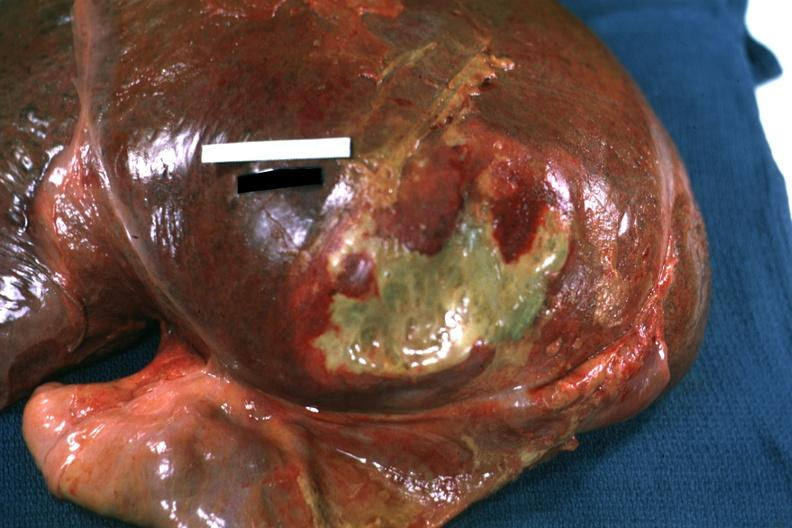how is right leaf of diaphragm reflected to show flat mass of yellow green pus quite example?
Answer the question using a single word or phrase. Good 